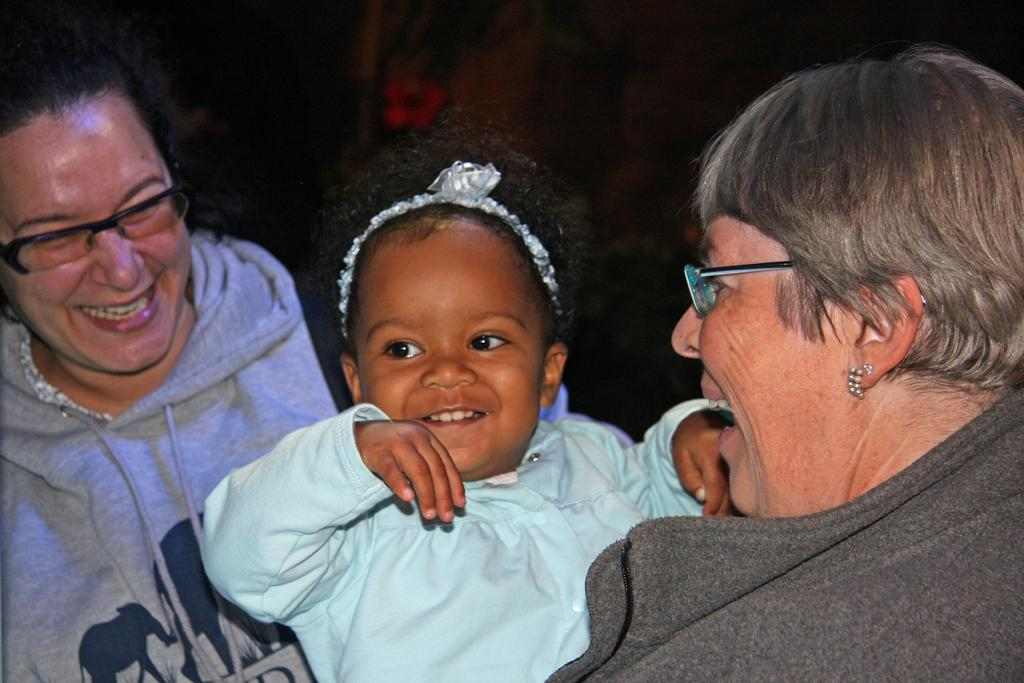How many people are in the image? There are three people in the image. What expressions do the people have? The people are smiling. What can be observed about the background of the image? The background of the image is dark. What title does the person in the middle of the image hold? There is no indication of any titles or positions in the image. Can you see any badges or insignias on the people in the image? There are no badges or insignias visible on the people in the image. 